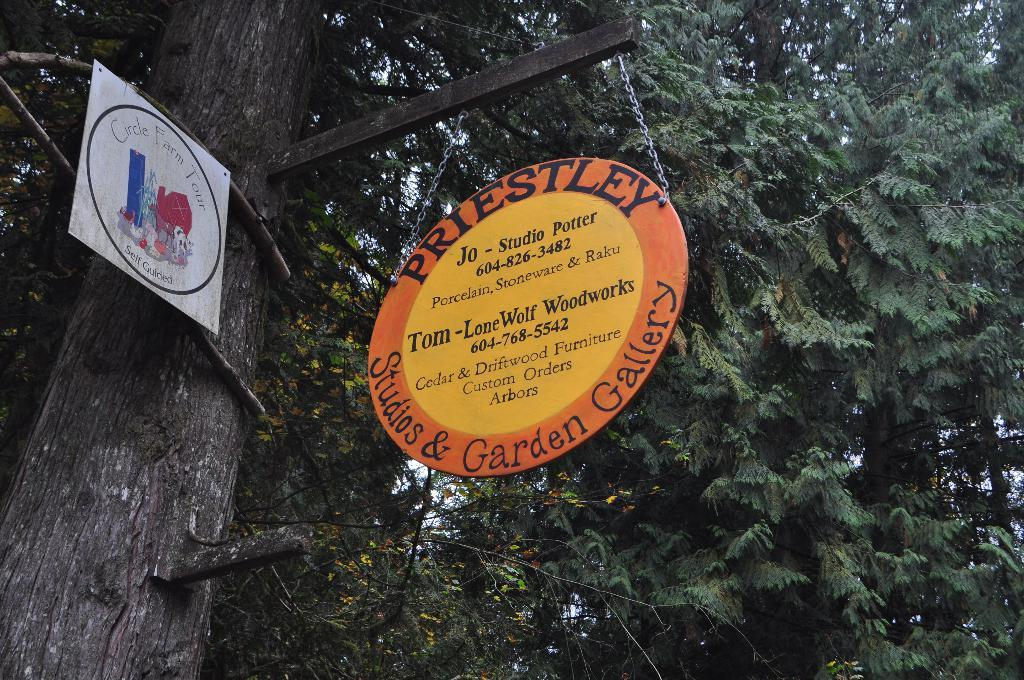What type of plant can be seen in the image? There is a tree in the image. What is attached to the tree? Boards are attached to the tree. What is written on the boards? Words are written on the boards. What part of the tree is visible in the image? Leaves are visible at the top of the image. How many hooks are hanging from the tree in the image? There are no hooks visible in the image; only boards with words are attached to the tree. 